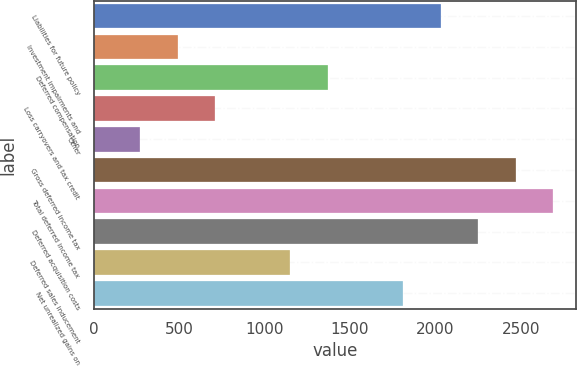<chart> <loc_0><loc_0><loc_500><loc_500><bar_chart><fcel>Liabilities for future policy<fcel>Investment impairments and<fcel>Deferred compensation<fcel>Loss carryovers and tax credit<fcel>Other<fcel>Gross deferred income tax<fcel>Total deferred income tax<fcel>Deferred acquisition costs<fcel>Deferred sales inducement<fcel>Net unrealized gains on<nl><fcel>2031.1<fcel>491.8<fcel>1371.4<fcel>711.7<fcel>271.9<fcel>2470.9<fcel>2690.8<fcel>2251<fcel>1151.5<fcel>1811.2<nl></chart> 